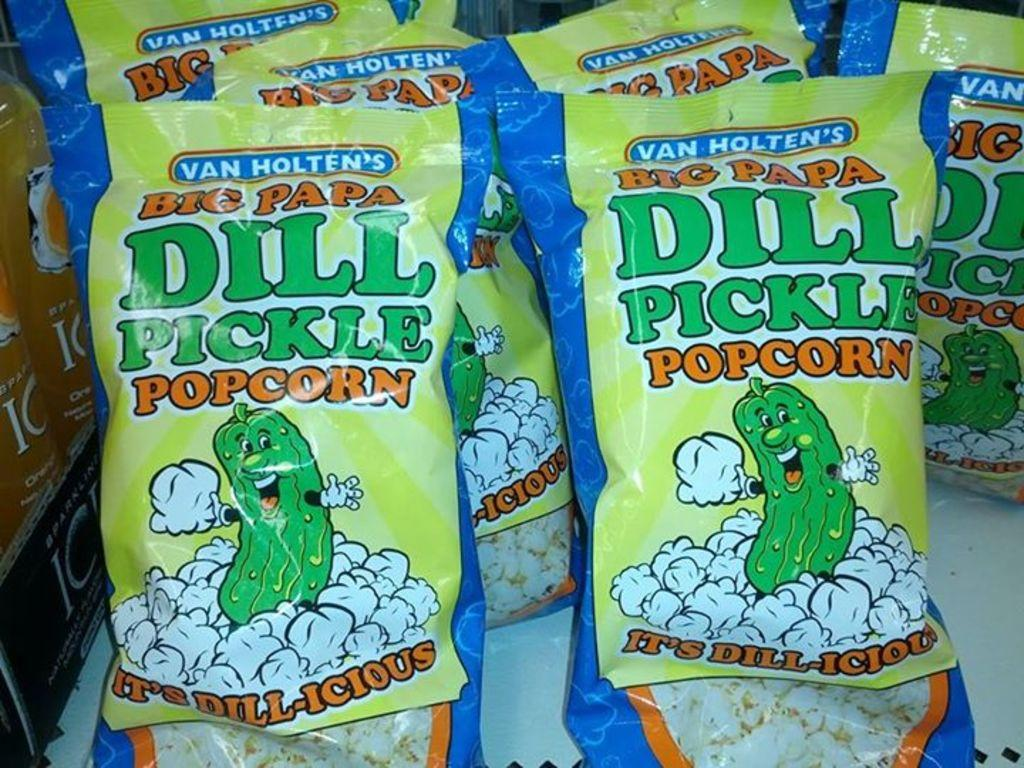What type of items are depicted on the packets in the image? The packets in the image have images and text on them. What is the drink in the image contained in? The drink in the image is in a bottle. Can you describe the black color object in the image? There is a black color object in the image, but without more information, it's difficult to provide a detailed description. What type of yarn is being used to create the flame in the image? There is no yarn or flame present in the image. 